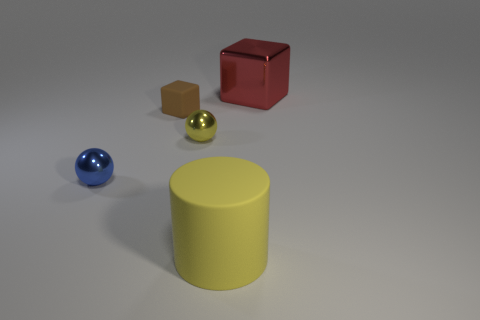What number of other things are the same material as the cylinder?
Provide a succinct answer. 1. Is the number of large shiny blocks to the right of the red shiny cube the same as the number of tiny blue cylinders?
Your response must be concise. Yes. What material is the big object that is in front of the small sphere that is left of the block to the left of the large red cube?
Provide a short and direct response. Rubber. What is the color of the shiny ball right of the brown matte cube?
Provide a short and direct response. Yellow. Is there anything else that has the same shape as the yellow rubber thing?
Your answer should be compact. No. There is a block on the left side of the metal thing that is right of the big yellow cylinder; what is its size?
Provide a short and direct response. Small. Are there an equal number of tiny things on the left side of the small rubber thing and yellow shiny objects behind the tiny blue sphere?
Make the answer very short. Yes. The other object that is the same material as the brown object is what color?
Provide a succinct answer. Yellow. Is the large red block made of the same material as the big object that is in front of the red shiny block?
Your response must be concise. No. The thing that is both behind the yellow sphere and left of the red object is what color?
Offer a very short reply. Brown. 